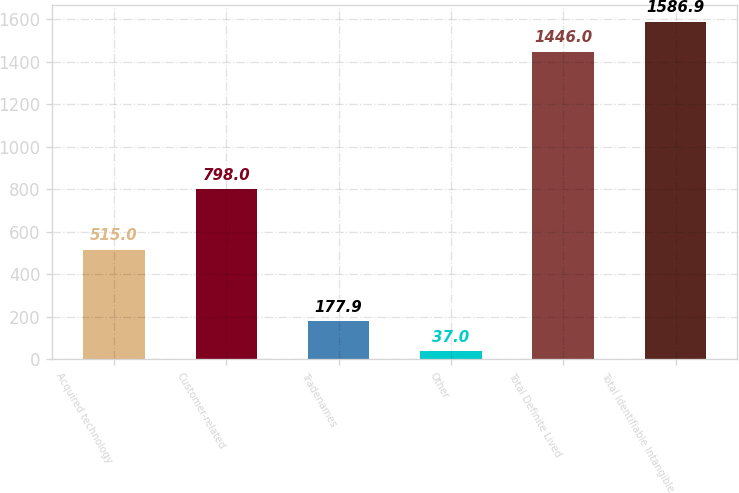Convert chart to OTSL. <chart><loc_0><loc_0><loc_500><loc_500><bar_chart><fcel>Acquired technology<fcel>Customer-related<fcel>Tradenames<fcel>Other<fcel>Total Definite Lived<fcel>Total Identifiable Intangible<nl><fcel>515<fcel>798<fcel>177.9<fcel>37<fcel>1446<fcel>1586.9<nl></chart> 